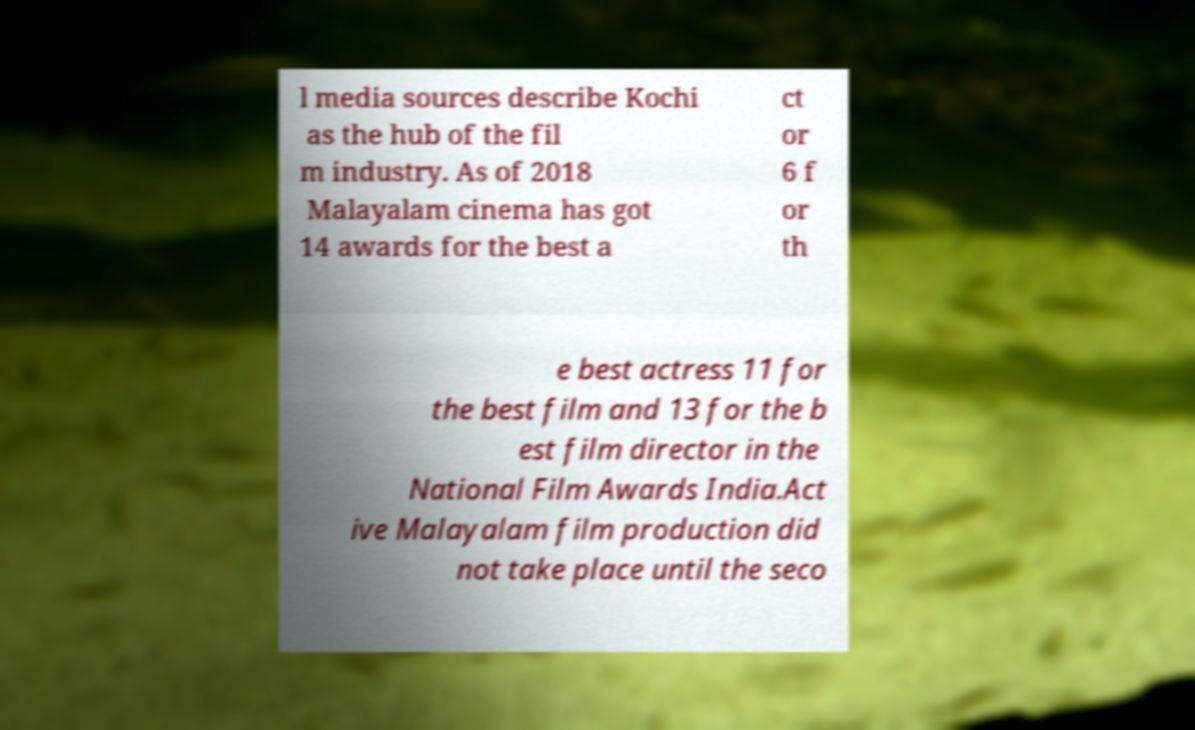Can you accurately transcribe the text from the provided image for me? l media sources describe Kochi as the hub of the fil m industry. As of 2018 Malayalam cinema has got 14 awards for the best a ct or 6 f or th e best actress 11 for the best film and 13 for the b est film director in the National Film Awards India.Act ive Malayalam film production did not take place until the seco 